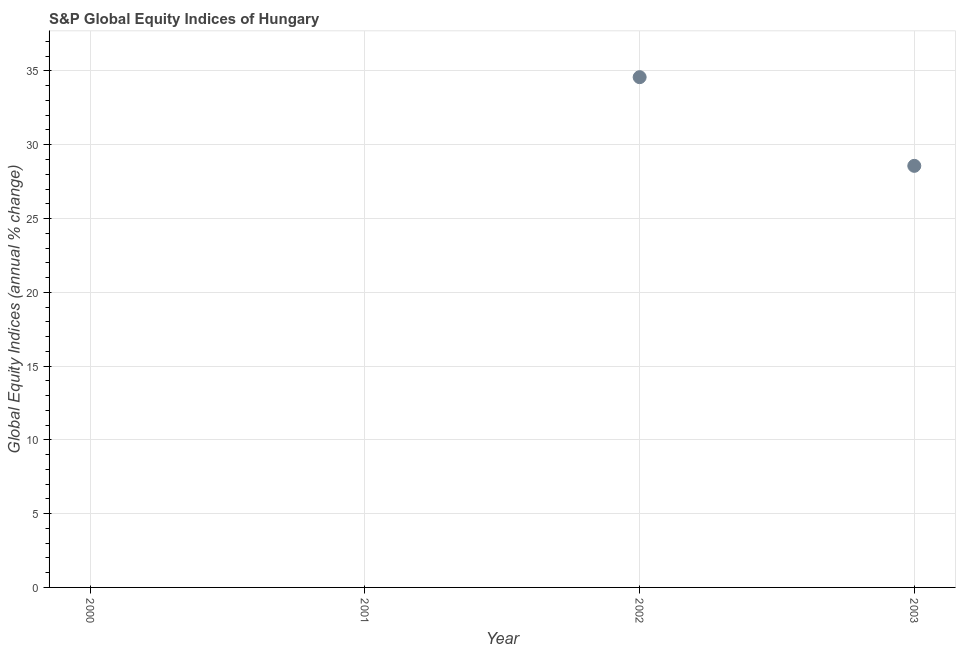What is the s&p global equity indices in 2001?
Make the answer very short. 0. Across all years, what is the maximum s&p global equity indices?
Give a very brief answer. 34.58. Across all years, what is the minimum s&p global equity indices?
Keep it short and to the point. 0. In which year was the s&p global equity indices maximum?
Give a very brief answer. 2002. What is the sum of the s&p global equity indices?
Provide a succinct answer. 63.15. What is the difference between the s&p global equity indices in 2002 and 2003?
Keep it short and to the point. 6.01. What is the average s&p global equity indices per year?
Provide a succinct answer. 15.79. What is the median s&p global equity indices?
Provide a short and direct response. 14.28. What is the ratio of the s&p global equity indices in 2002 to that in 2003?
Offer a very short reply. 1.21. Is the sum of the s&p global equity indices in 2002 and 2003 greater than the maximum s&p global equity indices across all years?
Provide a short and direct response. Yes. What is the difference between the highest and the lowest s&p global equity indices?
Give a very brief answer. 34.58. In how many years, is the s&p global equity indices greater than the average s&p global equity indices taken over all years?
Provide a succinct answer. 2. Does the s&p global equity indices monotonically increase over the years?
Your response must be concise. No. What is the difference between two consecutive major ticks on the Y-axis?
Offer a very short reply. 5. Are the values on the major ticks of Y-axis written in scientific E-notation?
Your answer should be very brief. No. Does the graph contain grids?
Ensure brevity in your answer.  Yes. What is the title of the graph?
Keep it short and to the point. S&P Global Equity Indices of Hungary. What is the label or title of the Y-axis?
Your answer should be compact. Global Equity Indices (annual % change). What is the Global Equity Indices (annual % change) in 2000?
Give a very brief answer. 0. What is the Global Equity Indices (annual % change) in 2002?
Your answer should be very brief. 34.58. What is the Global Equity Indices (annual % change) in 2003?
Your response must be concise. 28.57. What is the difference between the Global Equity Indices (annual % change) in 2002 and 2003?
Give a very brief answer. 6.01. What is the ratio of the Global Equity Indices (annual % change) in 2002 to that in 2003?
Give a very brief answer. 1.21. 